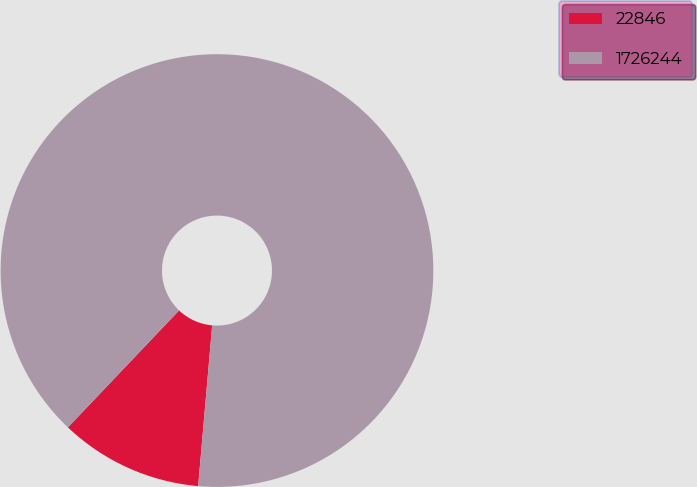Convert chart. <chart><loc_0><loc_0><loc_500><loc_500><pie_chart><fcel>22846<fcel>1726244<nl><fcel>10.71%<fcel>89.29%<nl></chart> 